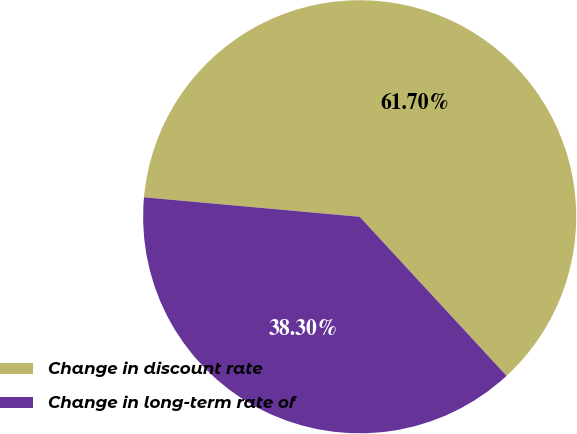Convert chart. <chart><loc_0><loc_0><loc_500><loc_500><pie_chart><fcel>Change in discount rate<fcel>Change in long-term rate of<nl><fcel>61.7%<fcel>38.3%<nl></chart> 